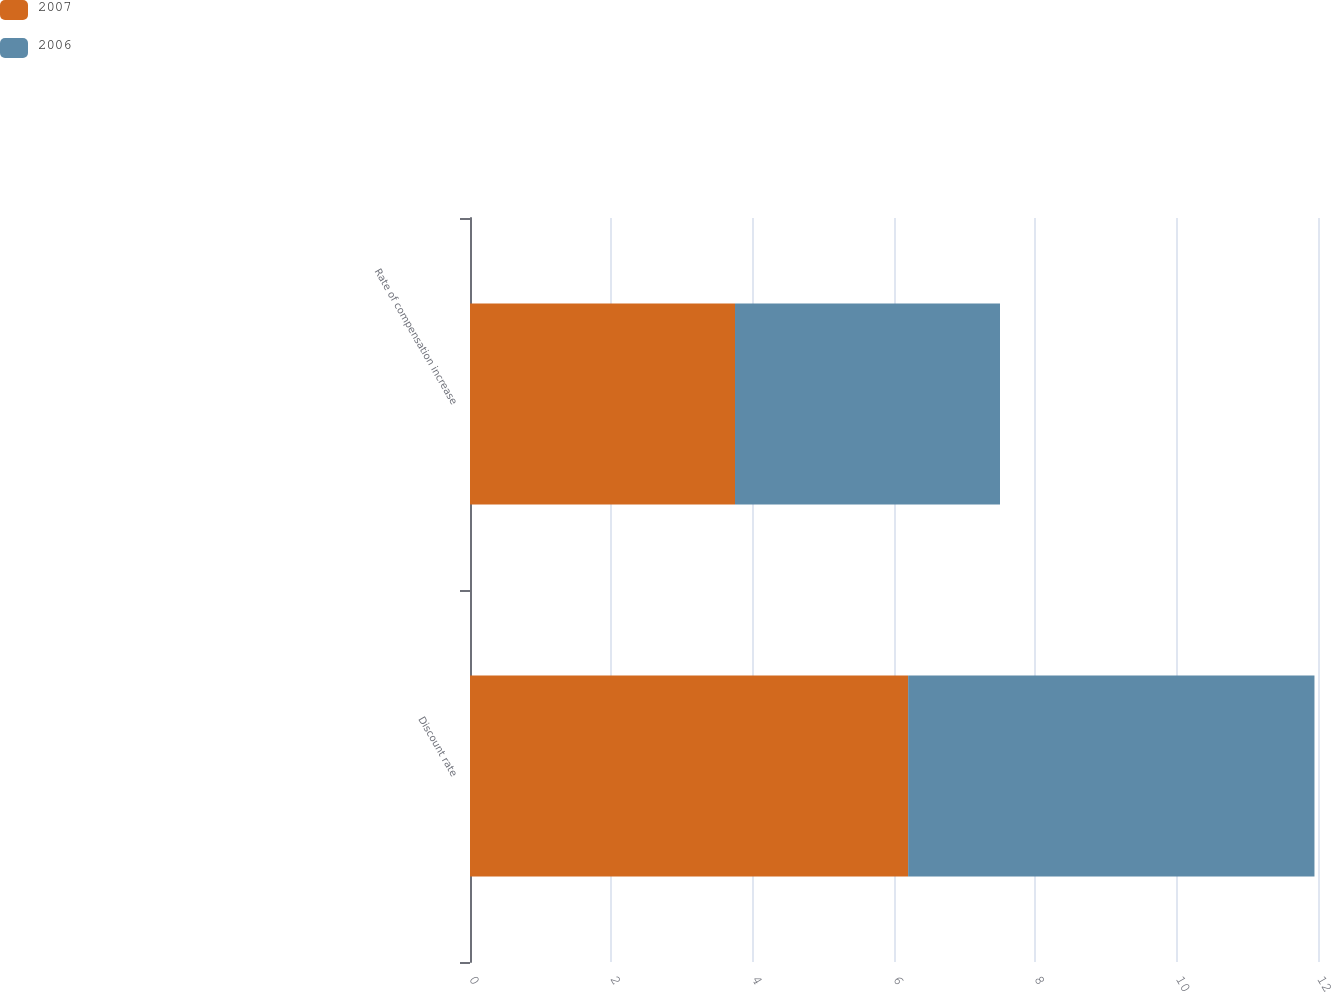Convert chart. <chart><loc_0><loc_0><loc_500><loc_500><stacked_bar_chart><ecel><fcel>Discount rate<fcel>Rate of compensation increase<nl><fcel>2007<fcel>6.2<fcel>3.75<nl><fcel>2006<fcel>5.75<fcel>3.75<nl></chart> 